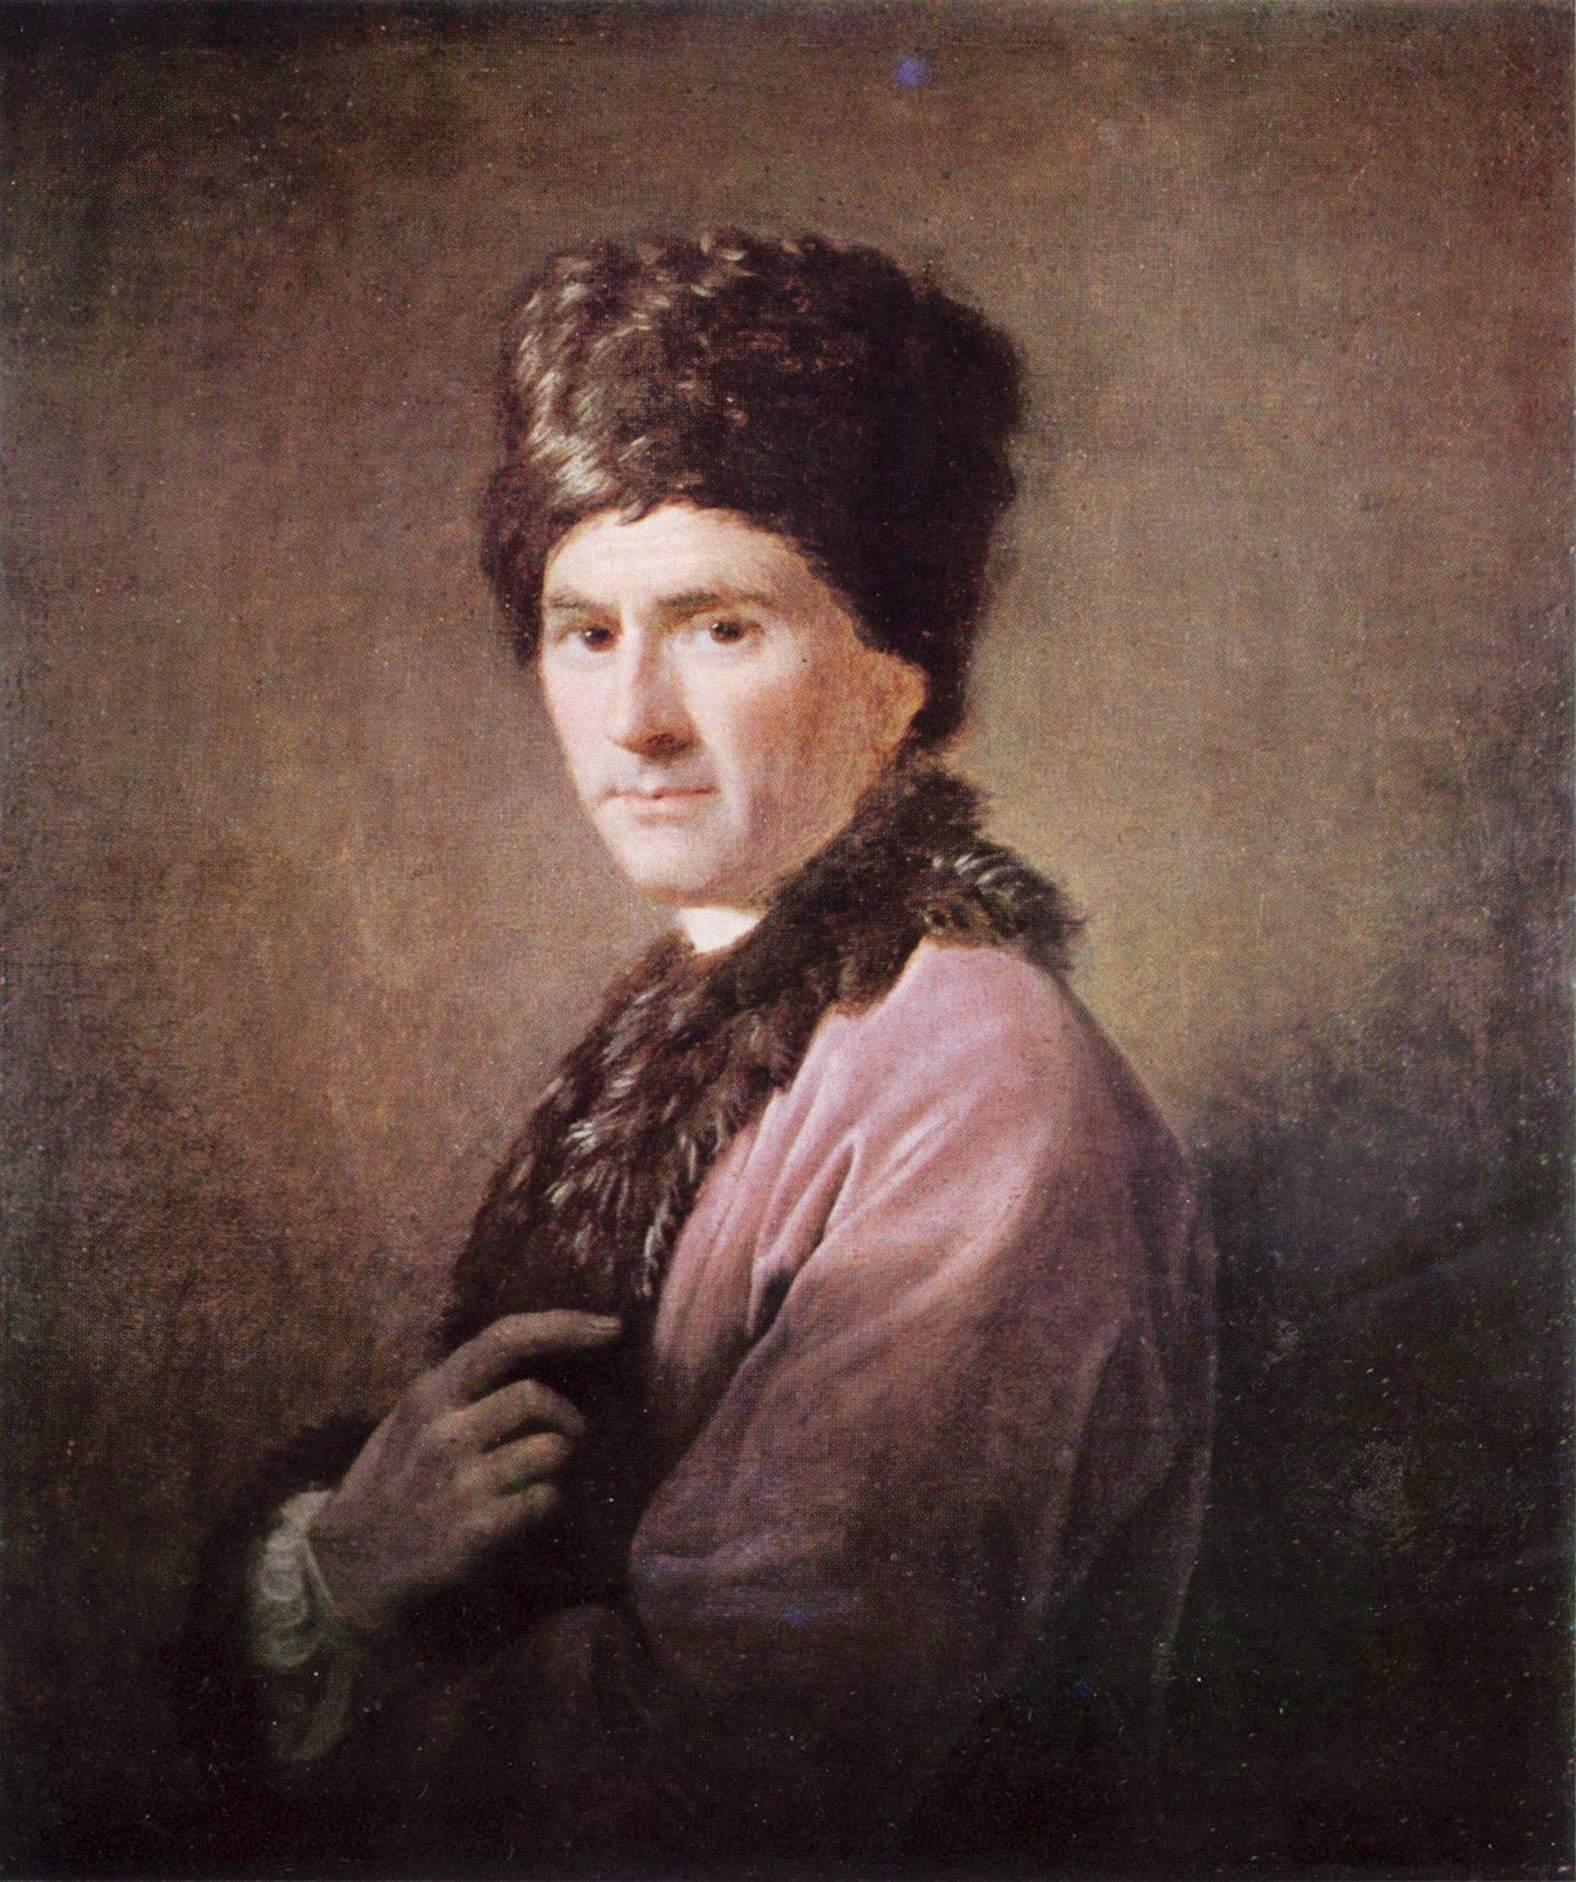Can you elaborate on the elements of the picture provided? Certainly, the painting depicts what appears to be a historical figure dressed in traditional attire. It features a man looking off to the side with an introspective gaze, suggesting a moment of contemplation or engagement with an unseen presence. His attire includes a fur hat and fur-lined coat, which indicate a status of wealth or importance and possibly a colder climate or era when such clothing was necessary. The medium appears to be oil on canvas, characterized by its rich textures and the ability to capture fine detail and depth. The use of light accentuates the man's facial features and the texture of the fur, while the brown monochromatic background serves to draw the viewer's focus to the subject. The style of the painting, including the brushwork and composition, may suggest a particular historical period, but does not definitively align with the Rococo genre, which is known for lighter and more ornate visuals, and typically does not characterize individual portraits in this manner. 